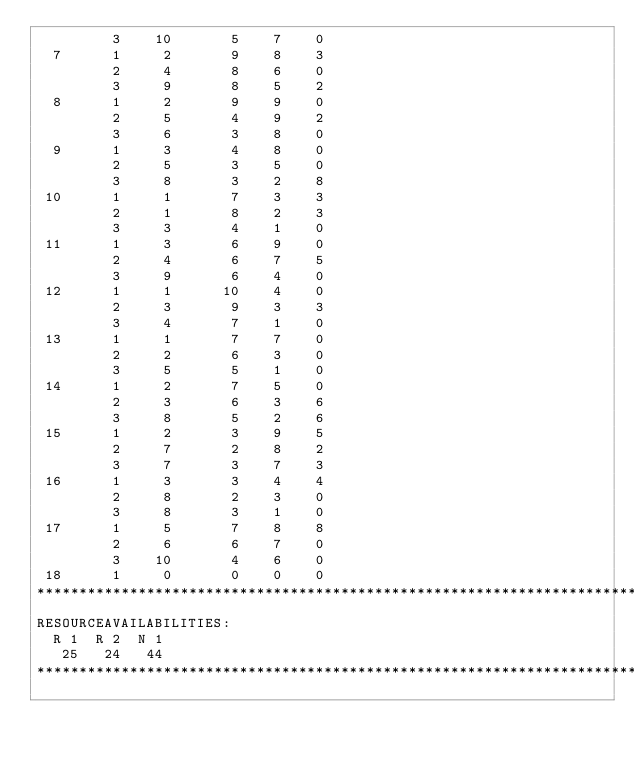Convert code to text. <code><loc_0><loc_0><loc_500><loc_500><_ObjectiveC_>         3    10       5    7    0
  7      1     2       9    8    3
         2     4       8    6    0
         3     9       8    5    2
  8      1     2       9    9    0
         2     5       4    9    2
         3     6       3    8    0
  9      1     3       4    8    0
         2     5       3    5    0
         3     8       3    2    8
 10      1     1       7    3    3
         2     1       8    2    3
         3     3       4    1    0
 11      1     3       6    9    0
         2     4       6    7    5
         3     9       6    4    0
 12      1     1      10    4    0
         2     3       9    3    3
         3     4       7    1    0
 13      1     1       7    7    0
         2     2       6    3    0
         3     5       5    1    0
 14      1     2       7    5    0
         2     3       6    3    6
         3     8       5    2    6
 15      1     2       3    9    5
         2     7       2    8    2
         3     7       3    7    3
 16      1     3       3    4    4
         2     8       2    3    0
         3     8       3    1    0
 17      1     5       7    8    8
         2     6       6    7    0
         3    10       4    6    0
 18      1     0       0    0    0
************************************************************************
RESOURCEAVAILABILITIES:
  R 1  R 2  N 1
   25   24   44
************************************************************************
</code> 